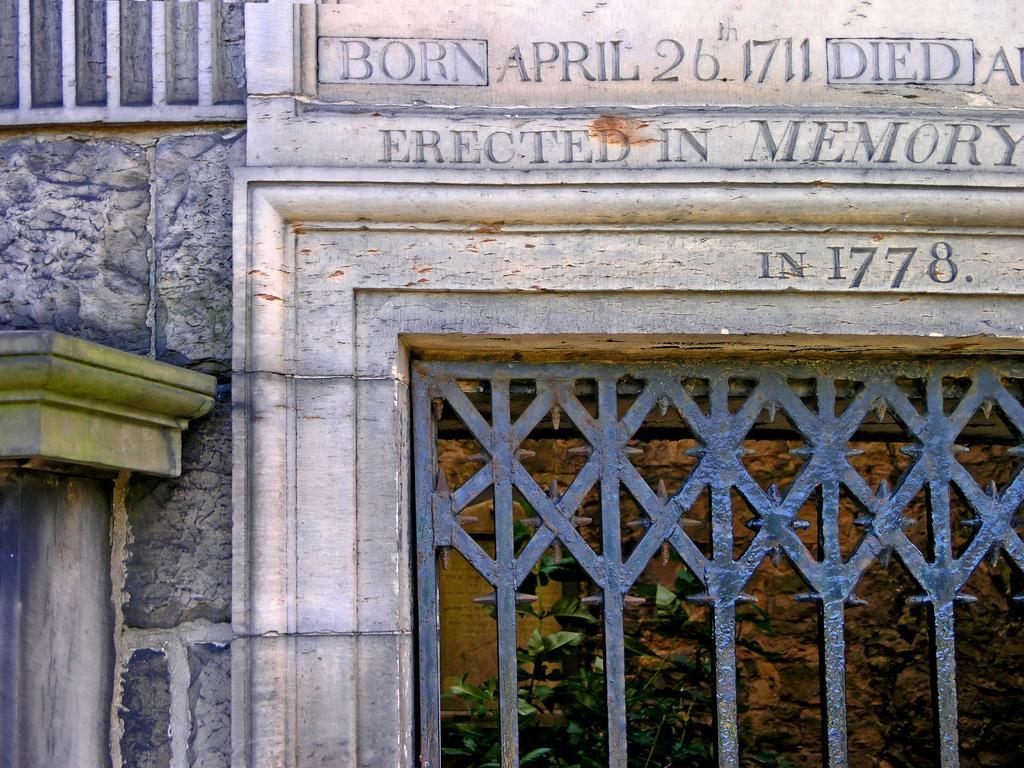Can you describe this image briefly? In this image there is a building, on that building there is some text and a iron gate. 